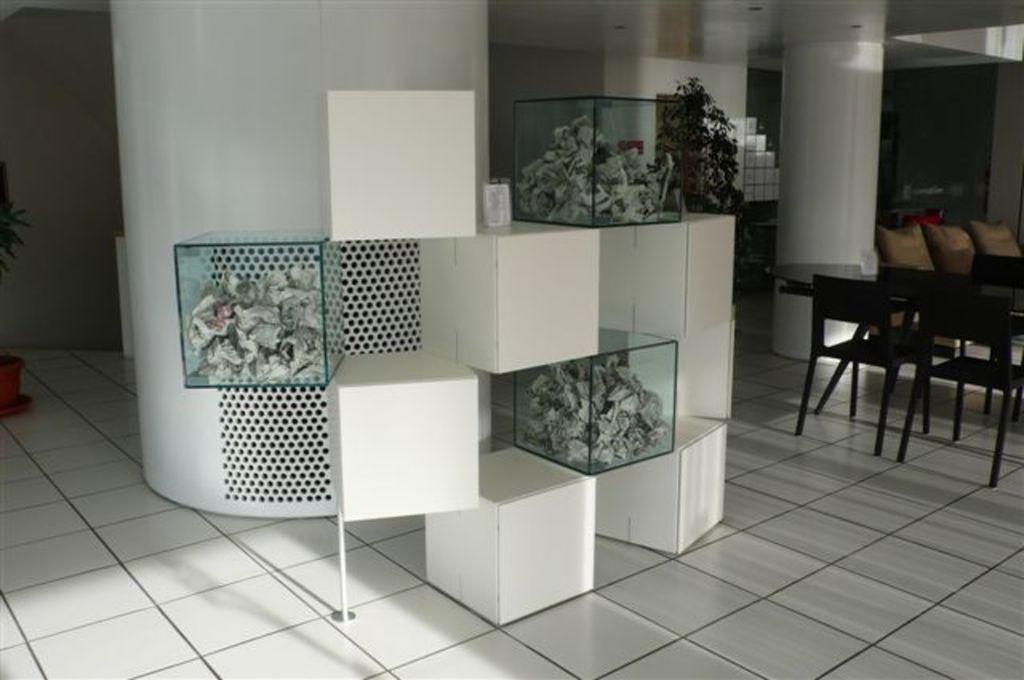In one or two sentences, can you explain what this image depicts? In this picture we can see the pillars, glass objects, floor, chairs, tables, plants, pot, few objects and the floor. 